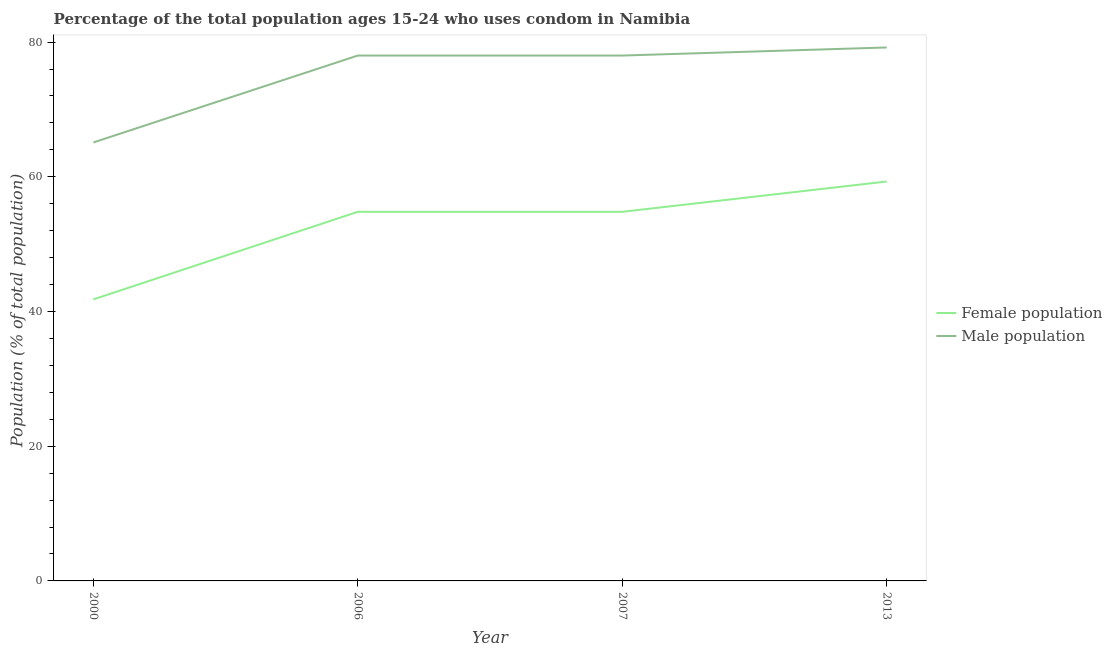Does the line corresponding to male population intersect with the line corresponding to female population?
Offer a very short reply. No. What is the female population in 2006?
Your answer should be very brief. 54.8. Across all years, what is the maximum male population?
Provide a succinct answer. 79.2. Across all years, what is the minimum female population?
Provide a short and direct response. 41.8. In which year was the female population minimum?
Provide a short and direct response. 2000. What is the total female population in the graph?
Give a very brief answer. 210.7. What is the difference between the female population in 2000 and that in 2013?
Your response must be concise. -17.5. What is the difference between the male population in 2006 and the female population in 2007?
Your response must be concise. 23.2. What is the average female population per year?
Give a very brief answer. 52.67. In the year 2013, what is the difference between the female population and male population?
Offer a very short reply. -19.9. In how many years, is the female population greater than 24 %?
Keep it short and to the point. 4. What is the ratio of the male population in 2000 to that in 2013?
Provide a short and direct response. 0.82. Is the female population in 2000 less than that in 2007?
Your answer should be very brief. Yes. What is the difference between the highest and the second highest male population?
Offer a terse response. 1.2. What is the difference between the highest and the lowest female population?
Your answer should be compact. 17.5. In how many years, is the female population greater than the average female population taken over all years?
Your answer should be compact. 3. Is the sum of the male population in 2000 and 2013 greater than the maximum female population across all years?
Make the answer very short. Yes. Does the female population monotonically increase over the years?
Your response must be concise. No. Is the male population strictly greater than the female population over the years?
Make the answer very short. Yes. Is the male population strictly less than the female population over the years?
Provide a succinct answer. No. How many years are there in the graph?
Provide a succinct answer. 4. Does the graph contain any zero values?
Make the answer very short. No. How many legend labels are there?
Make the answer very short. 2. What is the title of the graph?
Offer a terse response. Percentage of the total population ages 15-24 who uses condom in Namibia. What is the label or title of the X-axis?
Offer a terse response. Year. What is the label or title of the Y-axis?
Offer a very short reply. Population (% of total population) . What is the Population (% of total population)  in Female population in 2000?
Your response must be concise. 41.8. What is the Population (% of total population)  of Male population in 2000?
Your response must be concise. 65.1. What is the Population (% of total population)  of Female population in 2006?
Provide a short and direct response. 54.8. What is the Population (% of total population)  in Male population in 2006?
Keep it short and to the point. 78. What is the Population (% of total population)  in Female population in 2007?
Offer a terse response. 54.8. What is the Population (% of total population)  in Female population in 2013?
Offer a terse response. 59.3. What is the Population (% of total population)  in Male population in 2013?
Provide a short and direct response. 79.2. Across all years, what is the maximum Population (% of total population)  of Female population?
Ensure brevity in your answer.  59.3. Across all years, what is the maximum Population (% of total population)  of Male population?
Make the answer very short. 79.2. Across all years, what is the minimum Population (% of total population)  of Female population?
Provide a short and direct response. 41.8. Across all years, what is the minimum Population (% of total population)  in Male population?
Offer a very short reply. 65.1. What is the total Population (% of total population)  in Female population in the graph?
Provide a succinct answer. 210.7. What is the total Population (% of total population)  of Male population in the graph?
Offer a very short reply. 300.3. What is the difference between the Population (% of total population)  in Female population in 2000 and that in 2006?
Give a very brief answer. -13. What is the difference between the Population (% of total population)  in Male population in 2000 and that in 2006?
Your answer should be compact. -12.9. What is the difference between the Population (% of total population)  of Male population in 2000 and that in 2007?
Your response must be concise. -12.9. What is the difference between the Population (% of total population)  of Female population in 2000 and that in 2013?
Offer a very short reply. -17.5. What is the difference between the Population (% of total population)  of Male population in 2000 and that in 2013?
Your response must be concise. -14.1. What is the difference between the Population (% of total population)  of Female population in 2006 and that in 2007?
Your answer should be very brief. 0. What is the difference between the Population (% of total population)  in Male population in 2006 and that in 2007?
Provide a succinct answer. 0. What is the difference between the Population (% of total population)  of Female population in 2000 and the Population (% of total population)  of Male population in 2006?
Keep it short and to the point. -36.2. What is the difference between the Population (% of total population)  of Female population in 2000 and the Population (% of total population)  of Male population in 2007?
Provide a short and direct response. -36.2. What is the difference between the Population (% of total population)  in Female population in 2000 and the Population (% of total population)  in Male population in 2013?
Offer a terse response. -37.4. What is the difference between the Population (% of total population)  in Female population in 2006 and the Population (% of total population)  in Male population in 2007?
Offer a very short reply. -23.2. What is the difference between the Population (% of total population)  in Female population in 2006 and the Population (% of total population)  in Male population in 2013?
Ensure brevity in your answer.  -24.4. What is the difference between the Population (% of total population)  in Female population in 2007 and the Population (% of total population)  in Male population in 2013?
Ensure brevity in your answer.  -24.4. What is the average Population (% of total population)  in Female population per year?
Make the answer very short. 52.67. What is the average Population (% of total population)  of Male population per year?
Your answer should be compact. 75.08. In the year 2000, what is the difference between the Population (% of total population)  in Female population and Population (% of total population)  in Male population?
Your response must be concise. -23.3. In the year 2006, what is the difference between the Population (% of total population)  in Female population and Population (% of total population)  in Male population?
Offer a very short reply. -23.2. In the year 2007, what is the difference between the Population (% of total population)  in Female population and Population (% of total population)  in Male population?
Provide a succinct answer. -23.2. In the year 2013, what is the difference between the Population (% of total population)  of Female population and Population (% of total population)  of Male population?
Your answer should be very brief. -19.9. What is the ratio of the Population (% of total population)  in Female population in 2000 to that in 2006?
Your response must be concise. 0.76. What is the ratio of the Population (% of total population)  of Male population in 2000 to that in 2006?
Keep it short and to the point. 0.83. What is the ratio of the Population (% of total population)  in Female population in 2000 to that in 2007?
Your answer should be very brief. 0.76. What is the ratio of the Population (% of total population)  of Male population in 2000 to that in 2007?
Ensure brevity in your answer.  0.83. What is the ratio of the Population (% of total population)  in Female population in 2000 to that in 2013?
Keep it short and to the point. 0.7. What is the ratio of the Population (% of total population)  in Male population in 2000 to that in 2013?
Provide a short and direct response. 0.82. What is the ratio of the Population (% of total population)  in Female population in 2006 to that in 2007?
Your response must be concise. 1. What is the ratio of the Population (% of total population)  of Female population in 2006 to that in 2013?
Your response must be concise. 0.92. What is the ratio of the Population (% of total population)  of Male population in 2006 to that in 2013?
Your answer should be compact. 0.98. What is the ratio of the Population (% of total population)  in Female population in 2007 to that in 2013?
Offer a very short reply. 0.92. What is the difference between the highest and the lowest Population (% of total population)  of Female population?
Provide a succinct answer. 17.5. 